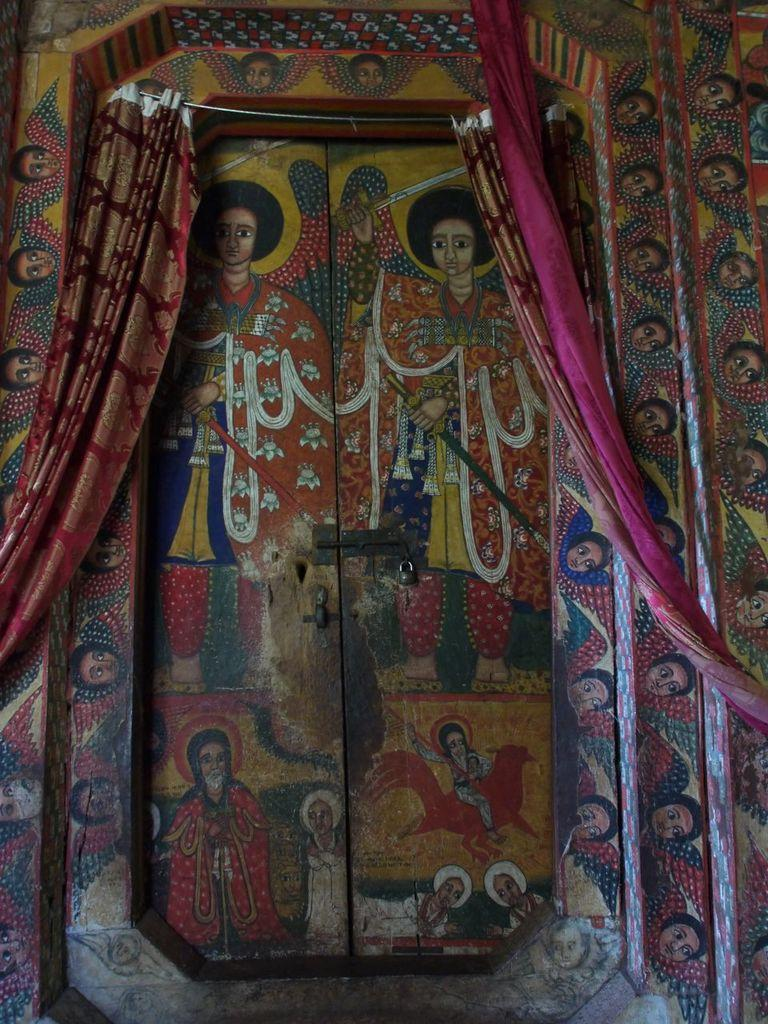What type of structure can be seen in the image? There is a wall in the image. Are there any openings in the wall? Yes, there are doors in the image. What decorative element is present in the image? There is a painting in the image. What type of window treatment is visible in the image? There are curtains in the image. What type of liquid can be seen flowing through the square in the image? There is no liquid or square present in the image. 